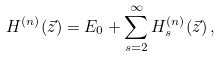<formula> <loc_0><loc_0><loc_500><loc_500>H ^ { ( n ) } ( \vec { z } ) = E _ { 0 } + \sum _ { s = 2 } ^ { \infty } H _ { s } ^ { ( n ) } ( \vec { z } ) \, ,</formula> 